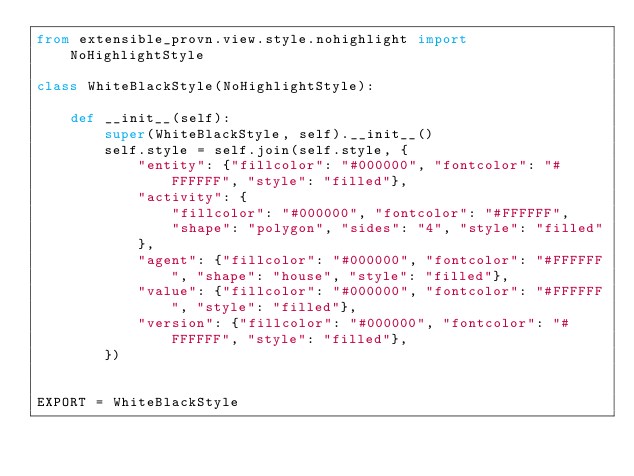<code> <loc_0><loc_0><loc_500><loc_500><_Python_>from extensible_provn.view.style.nohighlight import NoHighlightStyle

class WhiteBlackStyle(NoHighlightStyle):

    def __init__(self):
        super(WhiteBlackStyle, self).__init__()
        self.style = self.join(self.style, {
            "entity": {"fillcolor": "#000000", "fontcolor": "#FFFFFF", "style": "filled"},
            "activity": {
                "fillcolor": "#000000", "fontcolor": "#FFFFFF",
                "shape": "polygon", "sides": "4", "style": "filled"
            },
            "agent": {"fillcolor": "#000000", "fontcolor": "#FFFFFF", "shape": "house", "style": "filled"},
            "value": {"fillcolor": "#000000", "fontcolor": "#FFFFFF", "style": "filled"},
            "version": {"fillcolor": "#000000", "fontcolor": "#FFFFFF", "style": "filled"},
        })


EXPORT = WhiteBlackStyle</code> 